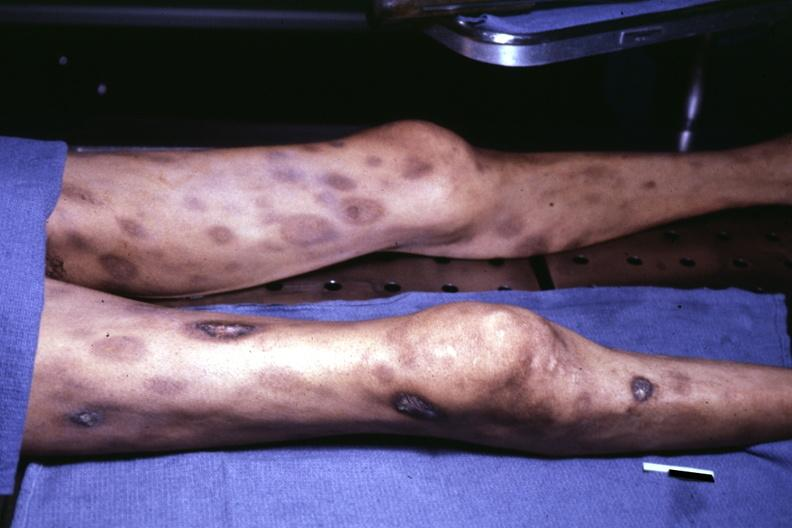what does ulceration look?
Answer the question using a single word or phrase. Like pyoderma gangrenosum 